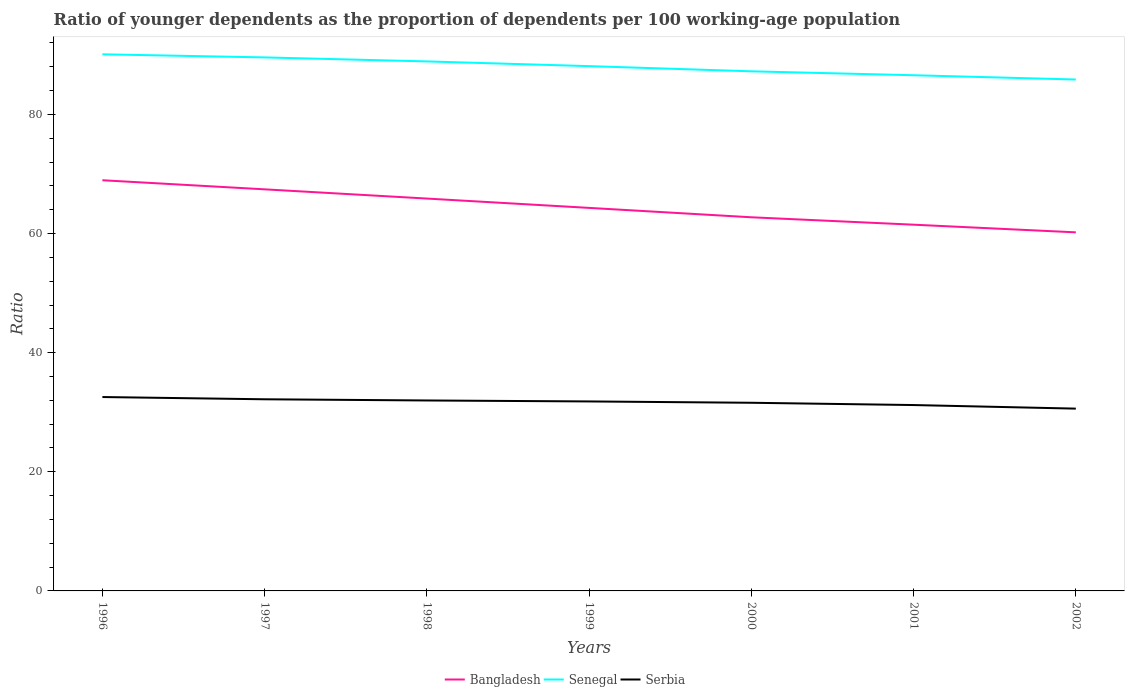Across all years, what is the maximum age dependency ratio(young) in Bangladesh?
Offer a terse response. 60.2. What is the total age dependency ratio(young) in Senegal in the graph?
Offer a terse response. 1.99. What is the difference between the highest and the second highest age dependency ratio(young) in Senegal?
Your response must be concise. 4.23. Are the values on the major ticks of Y-axis written in scientific E-notation?
Your response must be concise. No. Does the graph contain any zero values?
Provide a succinct answer. No. How are the legend labels stacked?
Provide a short and direct response. Horizontal. What is the title of the graph?
Keep it short and to the point. Ratio of younger dependents as the proportion of dependents per 100 working-age population. What is the label or title of the X-axis?
Make the answer very short. Years. What is the label or title of the Y-axis?
Your answer should be very brief. Ratio. What is the Ratio of Bangladesh in 1996?
Give a very brief answer. 68.95. What is the Ratio in Senegal in 1996?
Provide a short and direct response. 90.09. What is the Ratio of Serbia in 1996?
Your response must be concise. 32.55. What is the Ratio of Bangladesh in 1997?
Provide a short and direct response. 67.42. What is the Ratio of Senegal in 1997?
Your answer should be very brief. 89.57. What is the Ratio in Serbia in 1997?
Offer a very short reply. 32.17. What is the Ratio in Bangladesh in 1998?
Ensure brevity in your answer.  65.87. What is the Ratio in Senegal in 1998?
Keep it short and to the point. 88.9. What is the Ratio of Serbia in 1998?
Offer a very short reply. 31.97. What is the Ratio in Bangladesh in 1999?
Provide a short and direct response. 64.3. What is the Ratio of Senegal in 1999?
Make the answer very short. 88.1. What is the Ratio of Serbia in 1999?
Keep it short and to the point. 31.81. What is the Ratio of Bangladesh in 2000?
Offer a terse response. 62.73. What is the Ratio in Senegal in 2000?
Offer a very short reply. 87.23. What is the Ratio in Serbia in 2000?
Provide a short and direct response. 31.59. What is the Ratio of Bangladesh in 2001?
Offer a terse response. 61.48. What is the Ratio in Senegal in 2001?
Your answer should be compact. 86.58. What is the Ratio in Serbia in 2001?
Offer a very short reply. 31.2. What is the Ratio in Bangladesh in 2002?
Give a very brief answer. 60.2. What is the Ratio of Senegal in 2002?
Your answer should be compact. 85.85. What is the Ratio of Serbia in 2002?
Your response must be concise. 30.6. Across all years, what is the maximum Ratio in Bangladesh?
Your answer should be compact. 68.95. Across all years, what is the maximum Ratio of Senegal?
Your answer should be compact. 90.09. Across all years, what is the maximum Ratio in Serbia?
Your answer should be compact. 32.55. Across all years, what is the minimum Ratio of Bangladesh?
Offer a very short reply. 60.2. Across all years, what is the minimum Ratio in Senegal?
Provide a short and direct response. 85.85. Across all years, what is the minimum Ratio of Serbia?
Give a very brief answer. 30.6. What is the total Ratio of Bangladesh in the graph?
Your response must be concise. 450.95. What is the total Ratio of Senegal in the graph?
Your answer should be very brief. 616.32. What is the total Ratio of Serbia in the graph?
Provide a short and direct response. 221.9. What is the difference between the Ratio in Bangladesh in 1996 and that in 1997?
Provide a succinct answer. 1.53. What is the difference between the Ratio in Senegal in 1996 and that in 1997?
Keep it short and to the point. 0.52. What is the difference between the Ratio of Serbia in 1996 and that in 1997?
Your response must be concise. 0.38. What is the difference between the Ratio in Bangladesh in 1996 and that in 1998?
Make the answer very short. 3.08. What is the difference between the Ratio of Senegal in 1996 and that in 1998?
Give a very brief answer. 1.19. What is the difference between the Ratio in Serbia in 1996 and that in 1998?
Ensure brevity in your answer.  0.58. What is the difference between the Ratio in Bangladesh in 1996 and that in 1999?
Keep it short and to the point. 4.64. What is the difference between the Ratio of Senegal in 1996 and that in 1999?
Offer a very short reply. 1.99. What is the difference between the Ratio in Serbia in 1996 and that in 1999?
Give a very brief answer. 0.74. What is the difference between the Ratio in Bangladesh in 1996 and that in 2000?
Ensure brevity in your answer.  6.22. What is the difference between the Ratio of Senegal in 1996 and that in 2000?
Your answer should be very brief. 2.86. What is the difference between the Ratio in Serbia in 1996 and that in 2000?
Your response must be concise. 0.96. What is the difference between the Ratio in Bangladesh in 1996 and that in 2001?
Ensure brevity in your answer.  7.46. What is the difference between the Ratio of Senegal in 1996 and that in 2001?
Provide a short and direct response. 3.51. What is the difference between the Ratio of Serbia in 1996 and that in 2001?
Provide a succinct answer. 1.35. What is the difference between the Ratio of Bangladesh in 1996 and that in 2002?
Make the answer very short. 8.75. What is the difference between the Ratio in Senegal in 1996 and that in 2002?
Your response must be concise. 4.23. What is the difference between the Ratio in Serbia in 1996 and that in 2002?
Ensure brevity in your answer.  1.95. What is the difference between the Ratio in Bangladesh in 1997 and that in 1998?
Give a very brief answer. 1.55. What is the difference between the Ratio of Senegal in 1997 and that in 1998?
Provide a short and direct response. 0.67. What is the difference between the Ratio of Serbia in 1997 and that in 1998?
Your answer should be compact. 0.2. What is the difference between the Ratio of Bangladesh in 1997 and that in 1999?
Your answer should be very brief. 3.11. What is the difference between the Ratio in Senegal in 1997 and that in 1999?
Offer a terse response. 1.46. What is the difference between the Ratio of Serbia in 1997 and that in 1999?
Give a very brief answer. 0.36. What is the difference between the Ratio in Bangladesh in 1997 and that in 2000?
Your answer should be compact. 4.69. What is the difference between the Ratio in Senegal in 1997 and that in 2000?
Offer a very short reply. 2.34. What is the difference between the Ratio in Serbia in 1997 and that in 2000?
Your answer should be compact. 0.58. What is the difference between the Ratio of Bangladesh in 1997 and that in 2001?
Give a very brief answer. 5.93. What is the difference between the Ratio in Senegal in 1997 and that in 2001?
Your answer should be very brief. 2.99. What is the difference between the Ratio of Serbia in 1997 and that in 2001?
Your answer should be compact. 0.97. What is the difference between the Ratio in Bangladesh in 1997 and that in 2002?
Give a very brief answer. 7.22. What is the difference between the Ratio in Senegal in 1997 and that in 2002?
Your response must be concise. 3.71. What is the difference between the Ratio of Serbia in 1997 and that in 2002?
Give a very brief answer. 1.57. What is the difference between the Ratio of Bangladesh in 1998 and that in 1999?
Ensure brevity in your answer.  1.57. What is the difference between the Ratio in Senegal in 1998 and that in 1999?
Offer a very short reply. 0.79. What is the difference between the Ratio of Serbia in 1998 and that in 1999?
Make the answer very short. 0.16. What is the difference between the Ratio in Bangladesh in 1998 and that in 2000?
Ensure brevity in your answer.  3.14. What is the difference between the Ratio of Senegal in 1998 and that in 2000?
Make the answer very short. 1.66. What is the difference between the Ratio in Serbia in 1998 and that in 2000?
Your answer should be very brief. 0.38. What is the difference between the Ratio in Bangladesh in 1998 and that in 2001?
Your answer should be very brief. 4.39. What is the difference between the Ratio in Senegal in 1998 and that in 2001?
Keep it short and to the point. 2.32. What is the difference between the Ratio in Serbia in 1998 and that in 2001?
Offer a very short reply. 0.77. What is the difference between the Ratio of Bangladesh in 1998 and that in 2002?
Ensure brevity in your answer.  5.67. What is the difference between the Ratio of Senegal in 1998 and that in 2002?
Offer a terse response. 3.04. What is the difference between the Ratio of Serbia in 1998 and that in 2002?
Keep it short and to the point. 1.37. What is the difference between the Ratio of Bangladesh in 1999 and that in 2000?
Provide a short and direct response. 1.58. What is the difference between the Ratio of Senegal in 1999 and that in 2000?
Your answer should be compact. 0.87. What is the difference between the Ratio of Serbia in 1999 and that in 2000?
Give a very brief answer. 0.22. What is the difference between the Ratio in Bangladesh in 1999 and that in 2001?
Provide a short and direct response. 2.82. What is the difference between the Ratio of Senegal in 1999 and that in 2001?
Make the answer very short. 1.53. What is the difference between the Ratio in Serbia in 1999 and that in 2001?
Give a very brief answer. 0.61. What is the difference between the Ratio of Bangladesh in 1999 and that in 2002?
Offer a terse response. 4.11. What is the difference between the Ratio in Senegal in 1999 and that in 2002?
Make the answer very short. 2.25. What is the difference between the Ratio in Serbia in 1999 and that in 2002?
Offer a very short reply. 1.21. What is the difference between the Ratio in Bangladesh in 2000 and that in 2001?
Keep it short and to the point. 1.24. What is the difference between the Ratio of Senegal in 2000 and that in 2001?
Offer a very short reply. 0.66. What is the difference between the Ratio in Serbia in 2000 and that in 2001?
Provide a succinct answer. 0.38. What is the difference between the Ratio of Bangladesh in 2000 and that in 2002?
Keep it short and to the point. 2.53. What is the difference between the Ratio of Senegal in 2000 and that in 2002?
Offer a very short reply. 1.38. What is the difference between the Ratio in Serbia in 2000 and that in 2002?
Offer a terse response. 0.98. What is the difference between the Ratio of Bangladesh in 2001 and that in 2002?
Give a very brief answer. 1.29. What is the difference between the Ratio in Senegal in 2001 and that in 2002?
Your answer should be very brief. 0.72. What is the difference between the Ratio of Serbia in 2001 and that in 2002?
Your answer should be very brief. 0.6. What is the difference between the Ratio in Bangladesh in 1996 and the Ratio in Senegal in 1997?
Your answer should be very brief. -20.62. What is the difference between the Ratio of Bangladesh in 1996 and the Ratio of Serbia in 1997?
Your answer should be very brief. 36.77. What is the difference between the Ratio of Senegal in 1996 and the Ratio of Serbia in 1997?
Make the answer very short. 57.92. What is the difference between the Ratio in Bangladesh in 1996 and the Ratio in Senegal in 1998?
Give a very brief answer. -19.95. What is the difference between the Ratio of Bangladesh in 1996 and the Ratio of Serbia in 1998?
Your answer should be very brief. 36.97. What is the difference between the Ratio of Senegal in 1996 and the Ratio of Serbia in 1998?
Keep it short and to the point. 58.12. What is the difference between the Ratio of Bangladesh in 1996 and the Ratio of Senegal in 1999?
Your answer should be very brief. -19.16. What is the difference between the Ratio in Bangladesh in 1996 and the Ratio in Serbia in 1999?
Provide a succinct answer. 37.14. What is the difference between the Ratio of Senegal in 1996 and the Ratio of Serbia in 1999?
Ensure brevity in your answer.  58.28. What is the difference between the Ratio of Bangladesh in 1996 and the Ratio of Senegal in 2000?
Your answer should be very brief. -18.28. What is the difference between the Ratio in Bangladesh in 1996 and the Ratio in Serbia in 2000?
Your answer should be very brief. 37.36. What is the difference between the Ratio in Senegal in 1996 and the Ratio in Serbia in 2000?
Offer a terse response. 58.5. What is the difference between the Ratio of Bangladesh in 1996 and the Ratio of Senegal in 2001?
Your answer should be compact. -17.63. What is the difference between the Ratio in Bangladesh in 1996 and the Ratio in Serbia in 2001?
Provide a short and direct response. 37.74. What is the difference between the Ratio in Senegal in 1996 and the Ratio in Serbia in 2001?
Your answer should be compact. 58.89. What is the difference between the Ratio of Bangladesh in 1996 and the Ratio of Senegal in 2002?
Provide a short and direct response. -16.91. What is the difference between the Ratio in Bangladesh in 1996 and the Ratio in Serbia in 2002?
Offer a very short reply. 38.34. What is the difference between the Ratio in Senegal in 1996 and the Ratio in Serbia in 2002?
Offer a very short reply. 59.49. What is the difference between the Ratio of Bangladesh in 1997 and the Ratio of Senegal in 1998?
Provide a short and direct response. -21.48. What is the difference between the Ratio in Bangladesh in 1997 and the Ratio in Serbia in 1998?
Your answer should be very brief. 35.45. What is the difference between the Ratio of Senegal in 1997 and the Ratio of Serbia in 1998?
Ensure brevity in your answer.  57.59. What is the difference between the Ratio of Bangladesh in 1997 and the Ratio of Senegal in 1999?
Your response must be concise. -20.68. What is the difference between the Ratio in Bangladesh in 1997 and the Ratio in Serbia in 1999?
Ensure brevity in your answer.  35.61. What is the difference between the Ratio of Senegal in 1997 and the Ratio of Serbia in 1999?
Give a very brief answer. 57.76. What is the difference between the Ratio in Bangladesh in 1997 and the Ratio in Senegal in 2000?
Provide a short and direct response. -19.81. What is the difference between the Ratio in Bangladesh in 1997 and the Ratio in Serbia in 2000?
Give a very brief answer. 35.83. What is the difference between the Ratio of Senegal in 1997 and the Ratio of Serbia in 2000?
Your answer should be very brief. 57.98. What is the difference between the Ratio of Bangladesh in 1997 and the Ratio of Senegal in 2001?
Your answer should be very brief. -19.16. What is the difference between the Ratio in Bangladesh in 1997 and the Ratio in Serbia in 2001?
Keep it short and to the point. 36.21. What is the difference between the Ratio of Senegal in 1997 and the Ratio of Serbia in 2001?
Keep it short and to the point. 58.36. What is the difference between the Ratio of Bangladesh in 1997 and the Ratio of Senegal in 2002?
Make the answer very short. -18.44. What is the difference between the Ratio in Bangladesh in 1997 and the Ratio in Serbia in 2002?
Ensure brevity in your answer.  36.81. What is the difference between the Ratio in Senegal in 1997 and the Ratio in Serbia in 2002?
Your answer should be compact. 58.96. What is the difference between the Ratio in Bangladesh in 1998 and the Ratio in Senegal in 1999?
Your response must be concise. -22.23. What is the difference between the Ratio of Bangladesh in 1998 and the Ratio of Serbia in 1999?
Your answer should be compact. 34.06. What is the difference between the Ratio in Senegal in 1998 and the Ratio in Serbia in 1999?
Your answer should be compact. 57.09. What is the difference between the Ratio in Bangladesh in 1998 and the Ratio in Senegal in 2000?
Offer a terse response. -21.36. What is the difference between the Ratio in Bangladesh in 1998 and the Ratio in Serbia in 2000?
Ensure brevity in your answer.  34.28. What is the difference between the Ratio in Senegal in 1998 and the Ratio in Serbia in 2000?
Your answer should be very brief. 57.31. What is the difference between the Ratio of Bangladesh in 1998 and the Ratio of Senegal in 2001?
Your response must be concise. -20.7. What is the difference between the Ratio of Bangladesh in 1998 and the Ratio of Serbia in 2001?
Keep it short and to the point. 34.67. What is the difference between the Ratio of Senegal in 1998 and the Ratio of Serbia in 2001?
Offer a very short reply. 57.69. What is the difference between the Ratio in Bangladesh in 1998 and the Ratio in Senegal in 2002?
Ensure brevity in your answer.  -19.98. What is the difference between the Ratio in Bangladesh in 1998 and the Ratio in Serbia in 2002?
Your answer should be very brief. 35.27. What is the difference between the Ratio of Senegal in 1998 and the Ratio of Serbia in 2002?
Offer a very short reply. 58.29. What is the difference between the Ratio in Bangladesh in 1999 and the Ratio in Senegal in 2000?
Your answer should be compact. -22.93. What is the difference between the Ratio of Bangladesh in 1999 and the Ratio of Serbia in 2000?
Give a very brief answer. 32.72. What is the difference between the Ratio of Senegal in 1999 and the Ratio of Serbia in 2000?
Give a very brief answer. 56.51. What is the difference between the Ratio in Bangladesh in 1999 and the Ratio in Senegal in 2001?
Ensure brevity in your answer.  -22.27. What is the difference between the Ratio of Bangladesh in 1999 and the Ratio of Serbia in 2001?
Your response must be concise. 33.1. What is the difference between the Ratio of Senegal in 1999 and the Ratio of Serbia in 2001?
Keep it short and to the point. 56.9. What is the difference between the Ratio of Bangladesh in 1999 and the Ratio of Senegal in 2002?
Offer a very short reply. -21.55. What is the difference between the Ratio in Bangladesh in 1999 and the Ratio in Serbia in 2002?
Provide a succinct answer. 33.7. What is the difference between the Ratio of Senegal in 1999 and the Ratio of Serbia in 2002?
Provide a short and direct response. 57.5. What is the difference between the Ratio in Bangladesh in 2000 and the Ratio in Senegal in 2001?
Offer a terse response. -23.85. What is the difference between the Ratio in Bangladesh in 2000 and the Ratio in Serbia in 2001?
Ensure brevity in your answer.  31.52. What is the difference between the Ratio of Senegal in 2000 and the Ratio of Serbia in 2001?
Provide a short and direct response. 56.03. What is the difference between the Ratio of Bangladesh in 2000 and the Ratio of Senegal in 2002?
Give a very brief answer. -23.13. What is the difference between the Ratio of Bangladesh in 2000 and the Ratio of Serbia in 2002?
Your answer should be compact. 32.12. What is the difference between the Ratio in Senegal in 2000 and the Ratio in Serbia in 2002?
Make the answer very short. 56.63. What is the difference between the Ratio of Bangladesh in 2001 and the Ratio of Senegal in 2002?
Keep it short and to the point. -24.37. What is the difference between the Ratio in Bangladesh in 2001 and the Ratio in Serbia in 2002?
Your answer should be very brief. 30.88. What is the difference between the Ratio in Senegal in 2001 and the Ratio in Serbia in 2002?
Your response must be concise. 55.97. What is the average Ratio of Bangladesh per year?
Give a very brief answer. 64.42. What is the average Ratio of Senegal per year?
Your answer should be compact. 88.05. What is the average Ratio in Serbia per year?
Keep it short and to the point. 31.7. In the year 1996, what is the difference between the Ratio in Bangladesh and Ratio in Senegal?
Your response must be concise. -21.14. In the year 1996, what is the difference between the Ratio of Bangladesh and Ratio of Serbia?
Provide a short and direct response. 36.4. In the year 1996, what is the difference between the Ratio of Senegal and Ratio of Serbia?
Ensure brevity in your answer.  57.54. In the year 1997, what is the difference between the Ratio of Bangladesh and Ratio of Senegal?
Give a very brief answer. -22.15. In the year 1997, what is the difference between the Ratio in Bangladesh and Ratio in Serbia?
Keep it short and to the point. 35.25. In the year 1997, what is the difference between the Ratio in Senegal and Ratio in Serbia?
Ensure brevity in your answer.  57.39. In the year 1998, what is the difference between the Ratio in Bangladesh and Ratio in Senegal?
Ensure brevity in your answer.  -23.02. In the year 1998, what is the difference between the Ratio in Bangladesh and Ratio in Serbia?
Provide a succinct answer. 33.9. In the year 1998, what is the difference between the Ratio in Senegal and Ratio in Serbia?
Make the answer very short. 56.92. In the year 1999, what is the difference between the Ratio in Bangladesh and Ratio in Senegal?
Provide a succinct answer. -23.8. In the year 1999, what is the difference between the Ratio in Bangladesh and Ratio in Serbia?
Offer a terse response. 32.49. In the year 1999, what is the difference between the Ratio of Senegal and Ratio of Serbia?
Provide a succinct answer. 56.29. In the year 2000, what is the difference between the Ratio in Bangladesh and Ratio in Senegal?
Keep it short and to the point. -24.5. In the year 2000, what is the difference between the Ratio in Bangladesh and Ratio in Serbia?
Give a very brief answer. 31.14. In the year 2000, what is the difference between the Ratio of Senegal and Ratio of Serbia?
Your answer should be compact. 55.64. In the year 2001, what is the difference between the Ratio of Bangladesh and Ratio of Senegal?
Give a very brief answer. -25.09. In the year 2001, what is the difference between the Ratio in Bangladesh and Ratio in Serbia?
Keep it short and to the point. 30.28. In the year 2001, what is the difference between the Ratio in Senegal and Ratio in Serbia?
Your answer should be very brief. 55.37. In the year 2002, what is the difference between the Ratio of Bangladesh and Ratio of Senegal?
Make the answer very short. -25.66. In the year 2002, what is the difference between the Ratio in Bangladesh and Ratio in Serbia?
Offer a terse response. 29.59. In the year 2002, what is the difference between the Ratio in Senegal and Ratio in Serbia?
Your answer should be compact. 55.25. What is the ratio of the Ratio of Bangladesh in 1996 to that in 1997?
Your answer should be compact. 1.02. What is the ratio of the Ratio in Senegal in 1996 to that in 1997?
Make the answer very short. 1.01. What is the ratio of the Ratio of Serbia in 1996 to that in 1997?
Your answer should be very brief. 1.01. What is the ratio of the Ratio in Bangladesh in 1996 to that in 1998?
Your answer should be very brief. 1.05. What is the ratio of the Ratio in Senegal in 1996 to that in 1998?
Provide a succinct answer. 1.01. What is the ratio of the Ratio in Serbia in 1996 to that in 1998?
Ensure brevity in your answer.  1.02. What is the ratio of the Ratio in Bangladesh in 1996 to that in 1999?
Your answer should be compact. 1.07. What is the ratio of the Ratio in Senegal in 1996 to that in 1999?
Your answer should be compact. 1.02. What is the ratio of the Ratio of Serbia in 1996 to that in 1999?
Your answer should be compact. 1.02. What is the ratio of the Ratio in Bangladesh in 1996 to that in 2000?
Provide a succinct answer. 1.1. What is the ratio of the Ratio of Senegal in 1996 to that in 2000?
Provide a short and direct response. 1.03. What is the ratio of the Ratio of Serbia in 1996 to that in 2000?
Ensure brevity in your answer.  1.03. What is the ratio of the Ratio of Bangladesh in 1996 to that in 2001?
Ensure brevity in your answer.  1.12. What is the ratio of the Ratio in Senegal in 1996 to that in 2001?
Keep it short and to the point. 1.04. What is the ratio of the Ratio in Serbia in 1996 to that in 2001?
Your response must be concise. 1.04. What is the ratio of the Ratio in Bangladesh in 1996 to that in 2002?
Make the answer very short. 1.15. What is the ratio of the Ratio in Senegal in 1996 to that in 2002?
Your response must be concise. 1.05. What is the ratio of the Ratio in Serbia in 1996 to that in 2002?
Give a very brief answer. 1.06. What is the ratio of the Ratio in Bangladesh in 1997 to that in 1998?
Provide a short and direct response. 1.02. What is the ratio of the Ratio of Senegal in 1997 to that in 1998?
Give a very brief answer. 1.01. What is the ratio of the Ratio in Bangladesh in 1997 to that in 1999?
Your response must be concise. 1.05. What is the ratio of the Ratio of Senegal in 1997 to that in 1999?
Give a very brief answer. 1.02. What is the ratio of the Ratio in Serbia in 1997 to that in 1999?
Provide a short and direct response. 1.01. What is the ratio of the Ratio in Bangladesh in 1997 to that in 2000?
Ensure brevity in your answer.  1.07. What is the ratio of the Ratio in Senegal in 1997 to that in 2000?
Make the answer very short. 1.03. What is the ratio of the Ratio in Serbia in 1997 to that in 2000?
Provide a short and direct response. 1.02. What is the ratio of the Ratio of Bangladesh in 1997 to that in 2001?
Give a very brief answer. 1.1. What is the ratio of the Ratio of Senegal in 1997 to that in 2001?
Your answer should be compact. 1.03. What is the ratio of the Ratio of Serbia in 1997 to that in 2001?
Make the answer very short. 1.03. What is the ratio of the Ratio of Bangladesh in 1997 to that in 2002?
Ensure brevity in your answer.  1.12. What is the ratio of the Ratio in Senegal in 1997 to that in 2002?
Ensure brevity in your answer.  1.04. What is the ratio of the Ratio in Serbia in 1997 to that in 2002?
Keep it short and to the point. 1.05. What is the ratio of the Ratio in Bangladesh in 1998 to that in 1999?
Provide a short and direct response. 1.02. What is the ratio of the Ratio of Senegal in 1998 to that in 1999?
Offer a terse response. 1.01. What is the ratio of the Ratio of Bangladesh in 1998 to that in 2000?
Give a very brief answer. 1.05. What is the ratio of the Ratio of Senegal in 1998 to that in 2000?
Make the answer very short. 1.02. What is the ratio of the Ratio of Serbia in 1998 to that in 2000?
Give a very brief answer. 1.01. What is the ratio of the Ratio of Bangladesh in 1998 to that in 2001?
Keep it short and to the point. 1.07. What is the ratio of the Ratio of Senegal in 1998 to that in 2001?
Give a very brief answer. 1.03. What is the ratio of the Ratio of Serbia in 1998 to that in 2001?
Your answer should be very brief. 1.02. What is the ratio of the Ratio in Bangladesh in 1998 to that in 2002?
Offer a terse response. 1.09. What is the ratio of the Ratio in Senegal in 1998 to that in 2002?
Your answer should be compact. 1.04. What is the ratio of the Ratio in Serbia in 1998 to that in 2002?
Offer a very short reply. 1.04. What is the ratio of the Ratio in Bangladesh in 1999 to that in 2000?
Give a very brief answer. 1.03. What is the ratio of the Ratio of Senegal in 1999 to that in 2000?
Ensure brevity in your answer.  1.01. What is the ratio of the Ratio in Serbia in 1999 to that in 2000?
Offer a very short reply. 1.01. What is the ratio of the Ratio in Bangladesh in 1999 to that in 2001?
Make the answer very short. 1.05. What is the ratio of the Ratio in Senegal in 1999 to that in 2001?
Your answer should be compact. 1.02. What is the ratio of the Ratio of Serbia in 1999 to that in 2001?
Make the answer very short. 1.02. What is the ratio of the Ratio in Bangladesh in 1999 to that in 2002?
Keep it short and to the point. 1.07. What is the ratio of the Ratio of Senegal in 1999 to that in 2002?
Provide a succinct answer. 1.03. What is the ratio of the Ratio of Serbia in 1999 to that in 2002?
Your response must be concise. 1.04. What is the ratio of the Ratio of Bangladesh in 2000 to that in 2001?
Give a very brief answer. 1.02. What is the ratio of the Ratio in Senegal in 2000 to that in 2001?
Provide a succinct answer. 1.01. What is the ratio of the Ratio in Serbia in 2000 to that in 2001?
Your answer should be very brief. 1.01. What is the ratio of the Ratio in Bangladesh in 2000 to that in 2002?
Your response must be concise. 1.04. What is the ratio of the Ratio in Senegal in 2000 to that in 2002?
Your response must be concise. 1.02. What is the ratio of the Ratio in Serbia in 2000 to that in 2002?
Provide a short and direct response. 1.03. What is the ratio of the Ratio in Bangladesh in 2001 to that in 2002?
Give a very brief answer. 1.02. What is the ratio of the Ratio in Senegal in 2001 to that in 2002?
Make the answer very short. 1.01. What is the ratio of the Ratio of Serbia in 2001 to that in 2002?
Your response must be concise. 1.02. What is the difference between the highest and the second highest Ratio in Bangladesh?
Provide a short and direct response. 1.53. What is the difference between the highest and the second highest Ratio of Senegal?
Your response must be concise. 0.52. What is the difference between the highest and the second highest Ratio in Serbia?
Ensure brevity in your answer.  0.38. What is the difference between the highest and the lowest Ratio of Bangladesh?
Give a very brief answer. 8.75. What is the difference between the highest and the lowest Ratio in Senegal?
Keep it short and to the point. 4.23. What is the difference between the highest and the lowest Ratio in Serbia?
Provide a short and direct response. 1.95. 